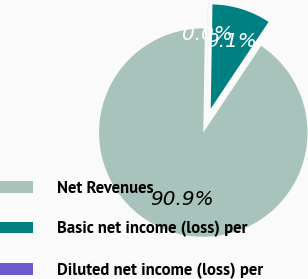Convert chart. <chart><loc_0><loc_0><loc_500><loc_500><pie_chart><fcel>Net Revenues<fcel>Basic net income (loss) per<fcel>Diluted net income (loss) per<nl><fcel>90.9%<fcel>9.1%<fcel>0.01%<nl></chart> 